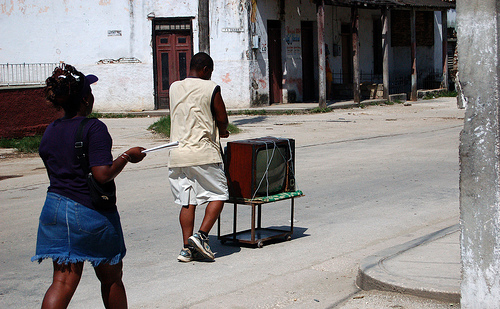<image>
Can you confirm if the television is above the roadway? Yes. The television is positioned above the roadway in the vertical space, higher up in the scene. 